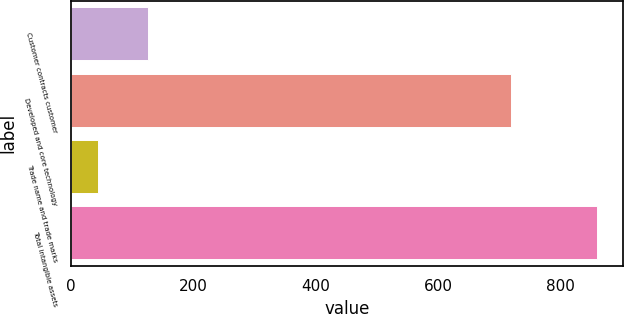Convert chart. <chart><loc_0><loc_0><loc_500><loc_500><bar_chart><fcel>Customer contracts customer<fcel>Developed and core technology<fcel>Trade name and trade marks<fcel>Total intangible assets<nl><fcel>125.5<fcel>719<fcel>44<fcel>859<nl></chart> 